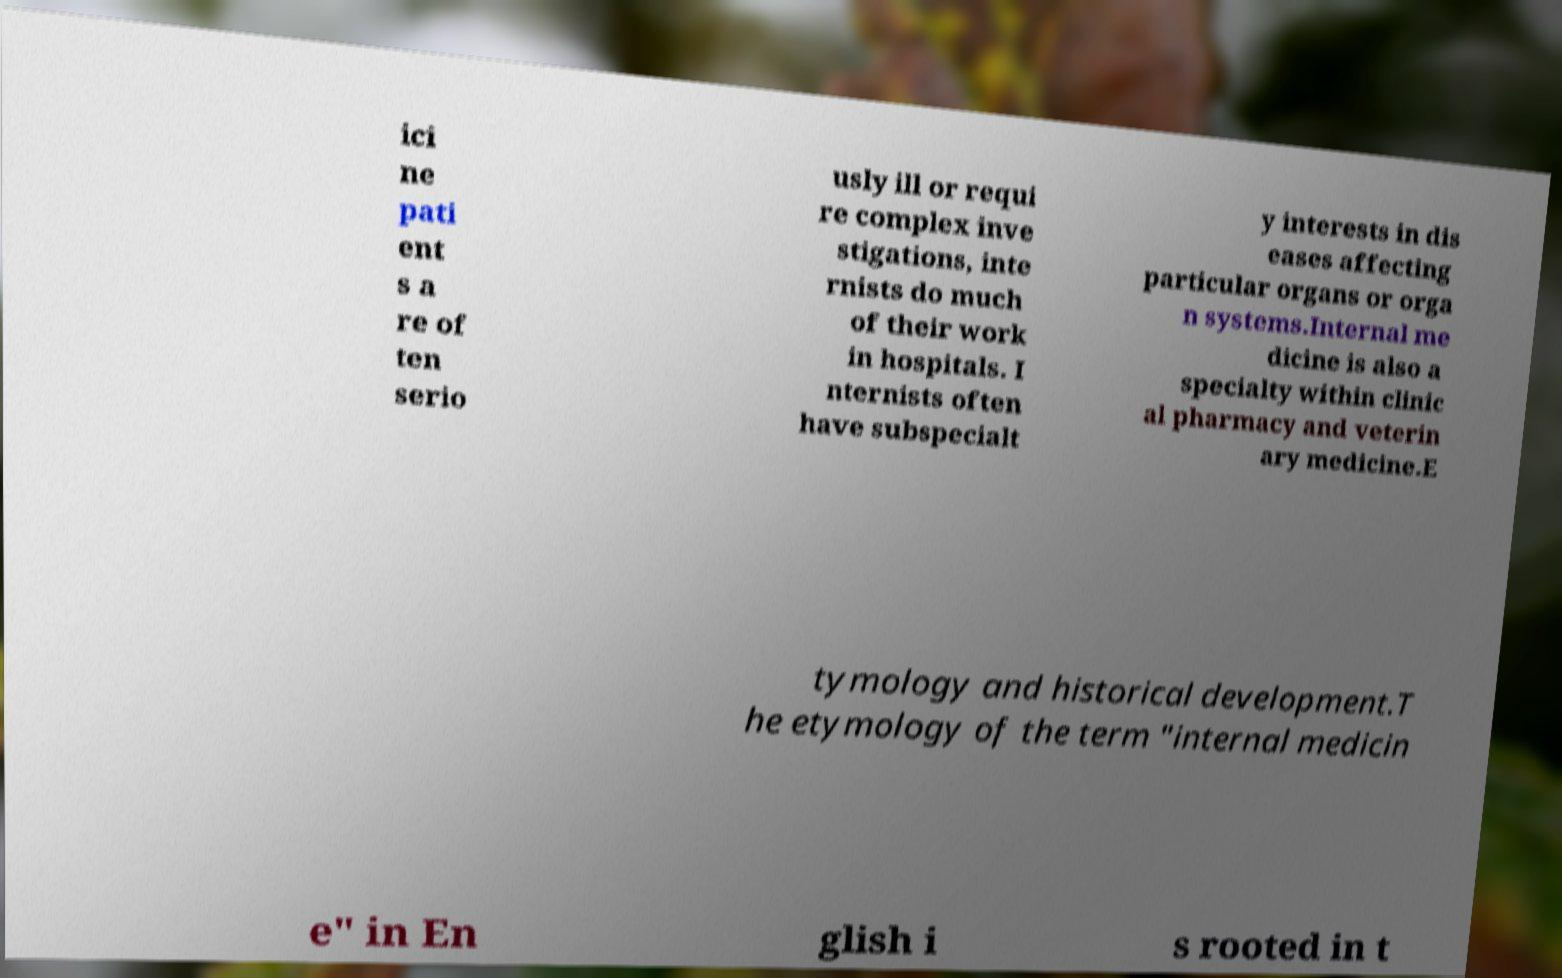Could you extract and type out the text from this image? ici ne pati ent s a re of ten serio usly ill or requi re complex inve stigations, inte rnists do much of their work in hospitals. I nternists often have subspecialt y interests in dis eases affecting particular organs or orga n systems.Internal me dicine is also a specialty within clinic al pharmacy and veterin ary medicine.E tymology and historical development.T he etymology of the term "internal medicin e" in En glish i s rooted in t 